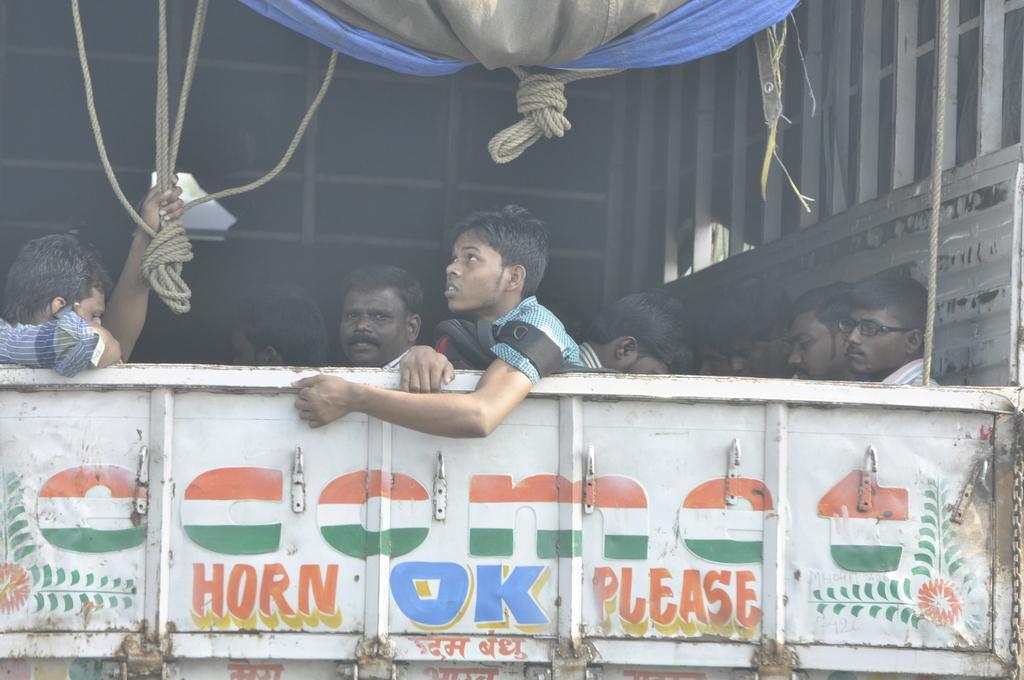Could you give a brief overview of what you see in this image? In this image there is a truck. The backside of the truck is captured in the image. There is text on the truck. There are people sitting inside the truck. To the left there is a man holding ropes in his hand. 